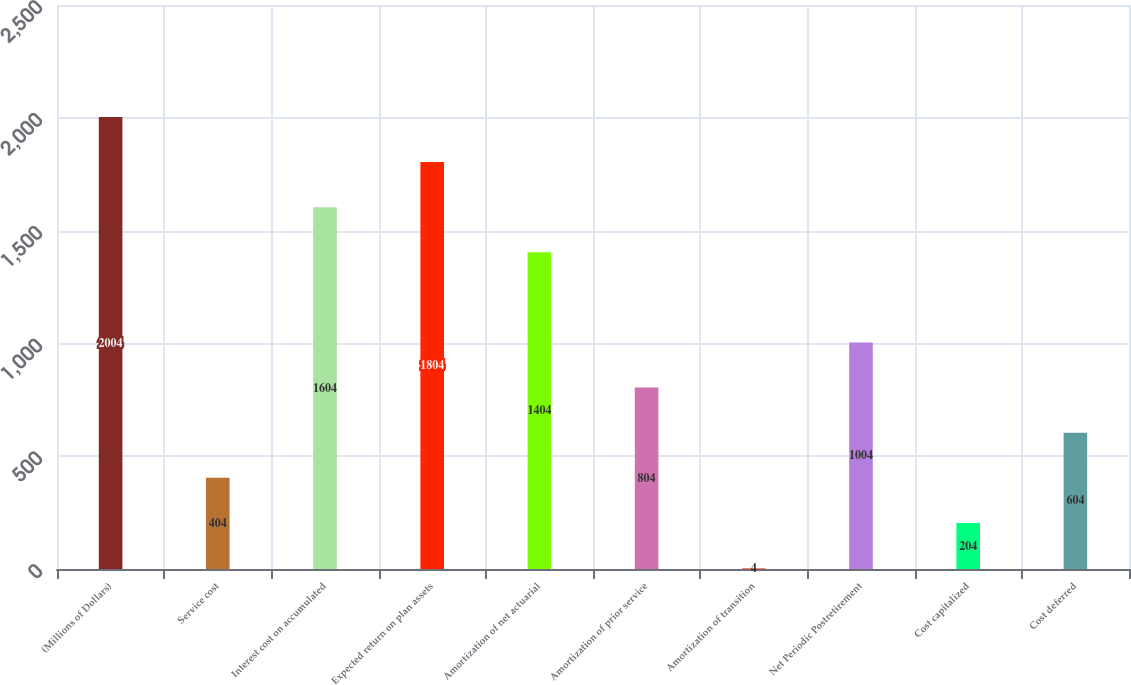Convert chart. <chart><loc_0><loc_0><loc_500><loc_500><bar_chart><fcel>(Millions of Dollars)<fcel>Service cost<fcel>Interest cost on accumulated<fcel>Expected return on plan assets<fcel>Amortization of net actuarial<fcel>Amortization of prior service<fcel>Amortization of transition<fcel>Net Periodic Postretirement<fcel>Cost capitalized<fcel>Cost deferred<nl><fcel>2004<fcel>404<fcel>1604<fcel>1804<fcel>1404<fcel>804<fcel>4<fcel>1004<fcel>204<fcel>604<nl></chart> 